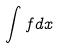Convert formula to latex. <formula><loc_0><loc_0><loc_500><loc_500>\int f d x</formula> 